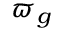<formula> <loc_0><loc_0><loc_500><loc_500>\varpi _ { g }</formula> 